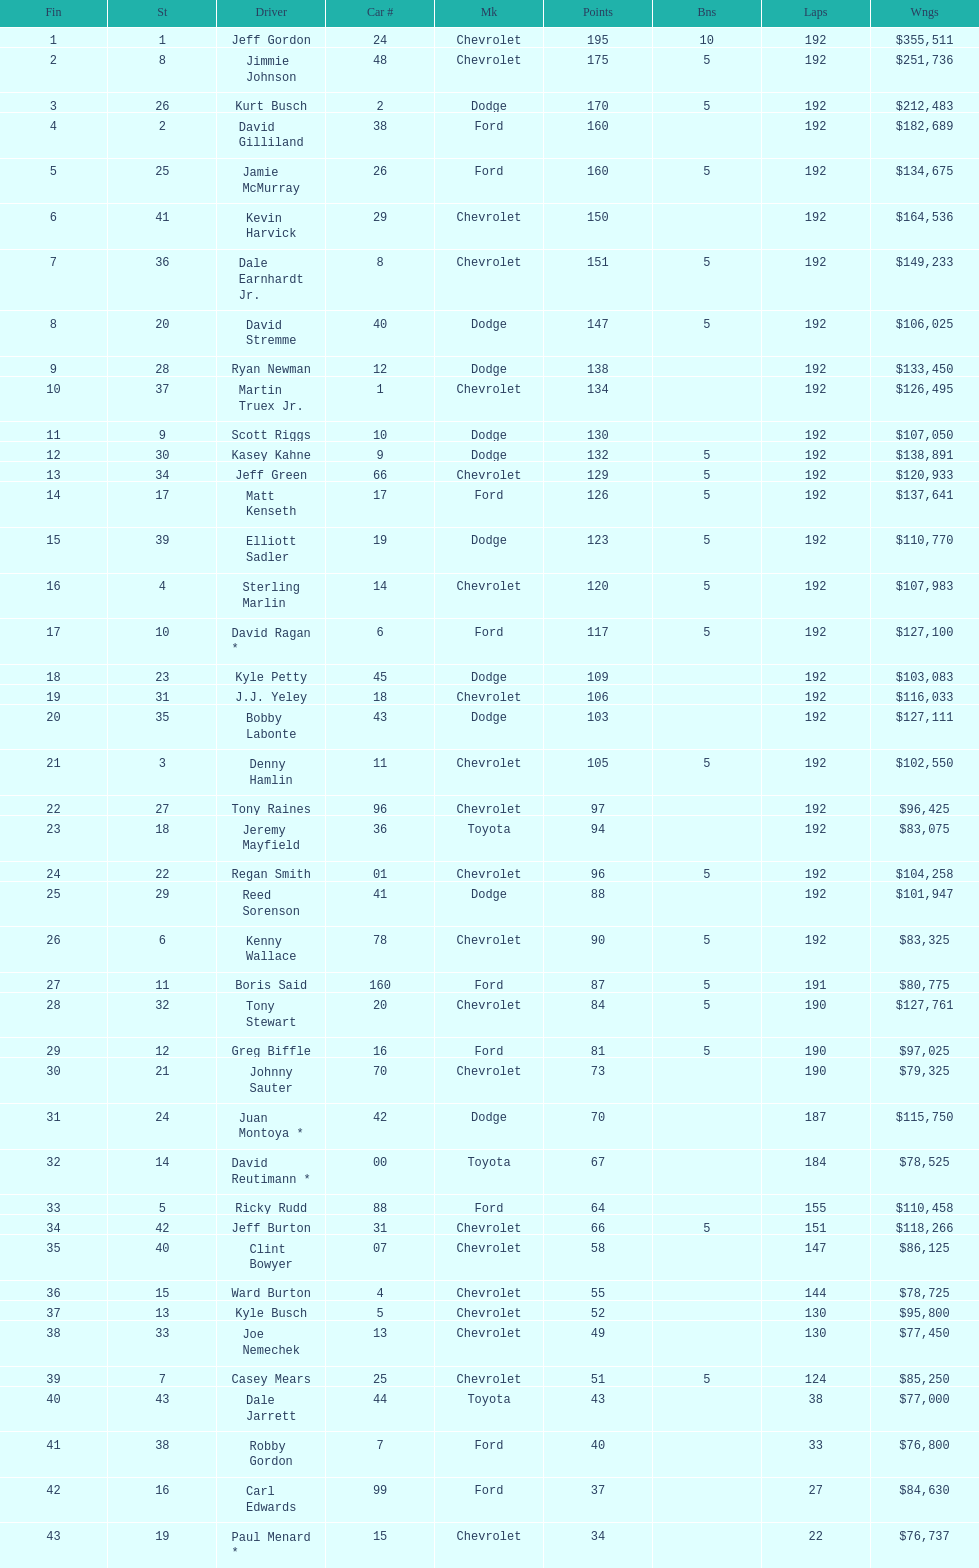What was the make of both jeff gordon's and jimmie johnson's race car? Chevrolet. 